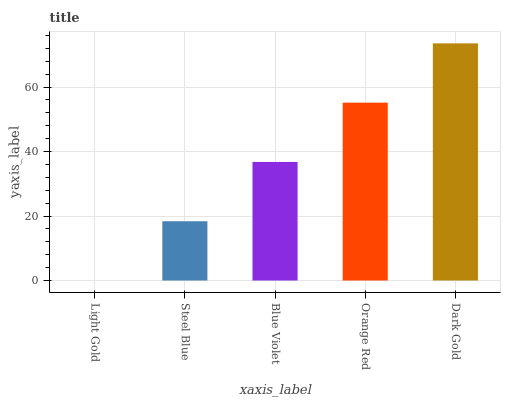Is Light Gold the minimum?
Answer yes or no. Yes. Is Dark Gold the maximum?
Answer yes or no. Yes. Is Steel Blue the minimum?
Answer yes or no. No. Is Steel Blue the maximum?
Answer yes or no. No. Is Steel Blue greater than Light Gold?
Answer yes or no. Yes. Is Light Gold less than Steel Blue?
Answer yes or no. Yes. Is Light Gold greater than Steel Blue?
Answer yes or no. No. Is Steel Blue less than Light Gold?
Answer yes or no. No. Is Blue Violet the high median?
Answer yes or no. Yes. Is Blue Violet the low median?
Answer yes or no. Yes. Is Orange Red the high median?
Answer yes or no. No. Is Dark Gold the low median?
Answer yes or no. No. 